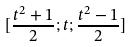Convert formula to latex. <formula><loc_0><loc_0><loc_500><loc_500>[ \frac { t ^ { 2 } + 1 } { 2 } ; t ; \frac { t ^ { 2 } - 1 } { 2 } ]</formula> 